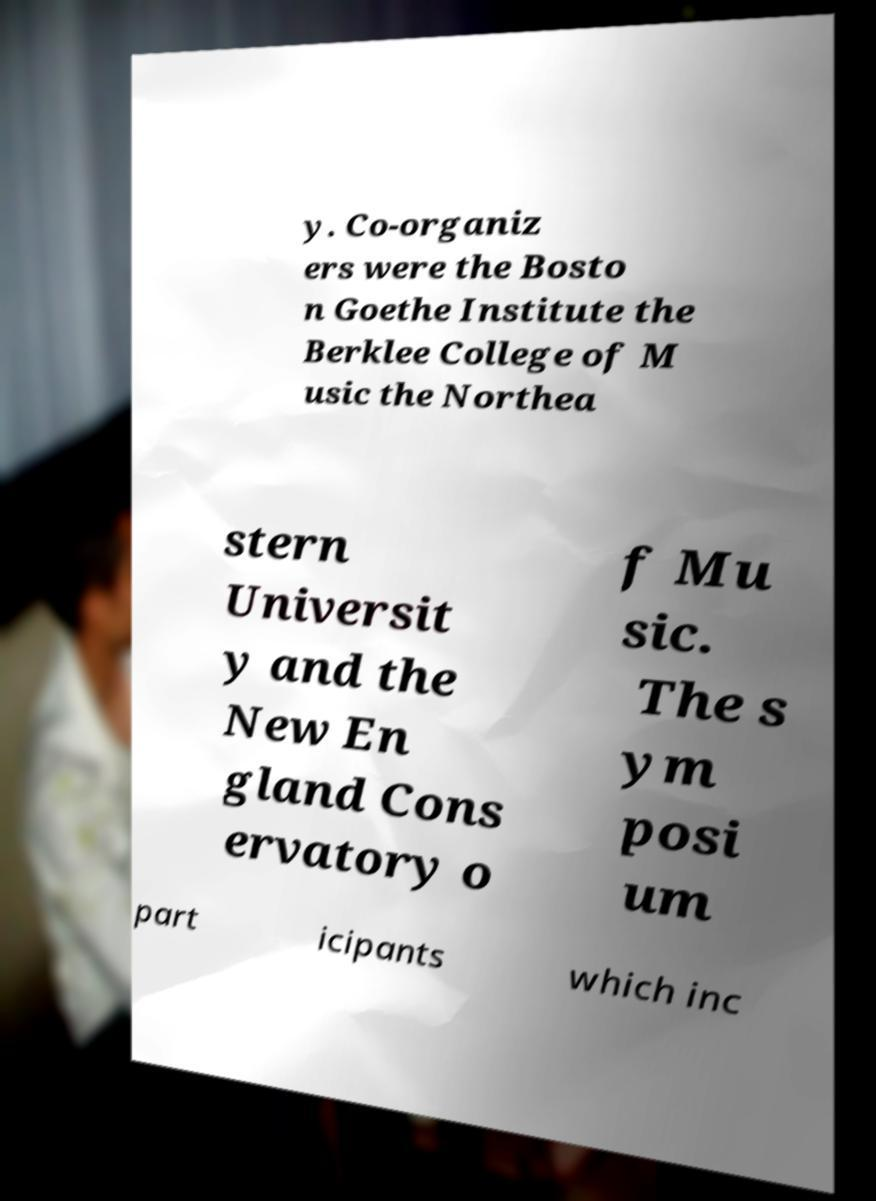Can you read and provide the text displayed in the image?This photo seems to have some interesting text. Can you extract and type it out for me? y. Co-organiz ers were the Bosto n Goethe Institute the Berklee College of M usic the Northea stern Universit y and the New En gland Cons ervatory o f Mu sic. The s ym posi um part icipants which inc 